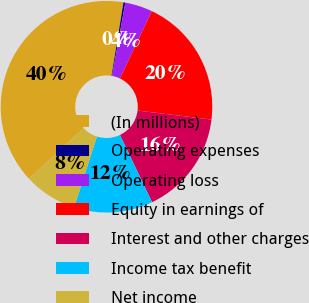Convert chart. <chart><loc_0><loc_0><loc_500><loc_500><pie_chart><fcel>(In millions)<fcel>Operating expenses<fcel>Operating loss<fcel>Equity in earnings of<fcel>Interest and other charges<fcel>Income tax benefit<fcel>Net income<nl><fcel>39.5%<fcel>0.28%<fcel>4.2%<fcel>19.89%<fcel>15.97%<fcel>12.04%<fcel>8.12%<nl></chart> 